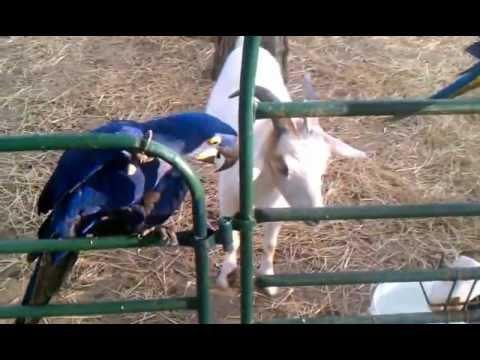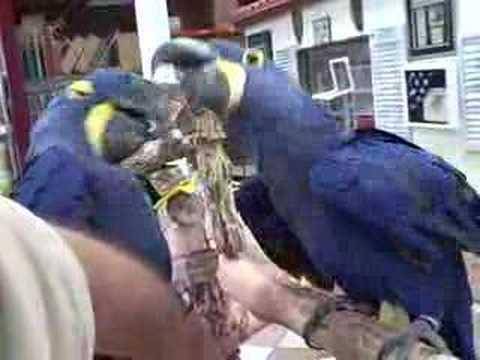The first image is the image on the left, the second image is the image on the right. Assess this claim about the two images: "There is a human petting a bird in at least one of the images.". Correct or not? Answer yes or no. No. The first image is the image on the left, the second image is the image on the right. Evaluate the accuracy of this statement regarding the images: "At least one image shows a person touching a parrot that is on its back.". Is it true? Answer yes or no. No. 